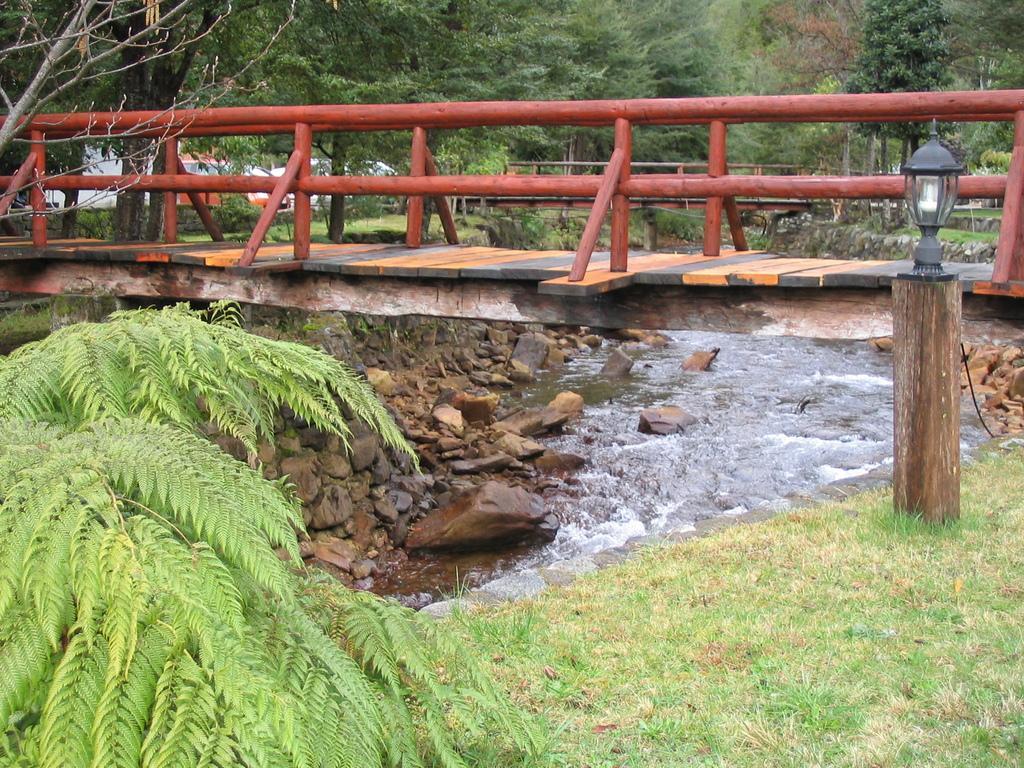Please provide a concise description of this image. In this image we can see bridge, trees, grass, water, stones, light and vehicles. 